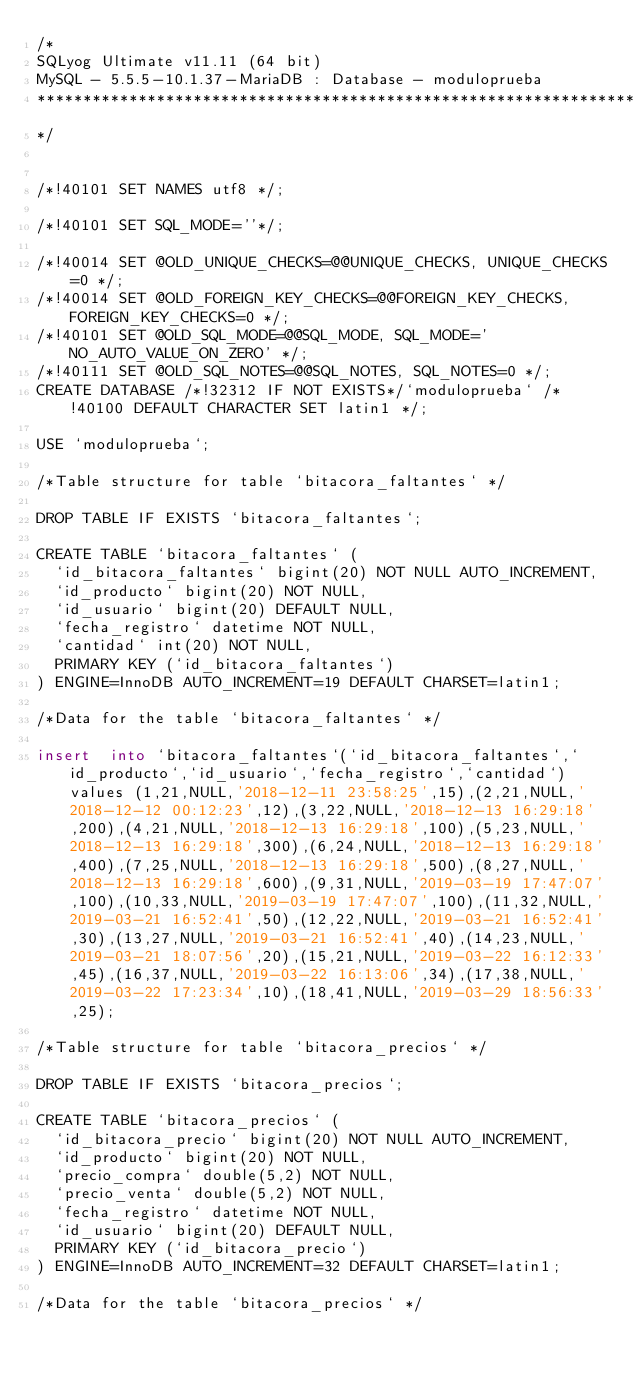Convert code to text. <code><loc_0><loc_0><loc_500><loc_500><_SQL_>/*
SQLyog Ultimate v11.11 (64 bit)
MySQL - 5.5.5-10.1.37-MariaDB : Database - moduloprueba
*********************************************************************
*/

/*!40101 SET NAMES utf8 */;

/*!40101 SET SQL_MODE=''*/;

/*!40014 SET @OLD_UNIQUE_CHECKS=@@UNIQUE_CHECKS, UNIQUE_CHECKS=0 */;
/*!40014 SET @OLD_FOREIGN_KEY_CHECKS=@@FOREIGN_KEY_CHECKS, FOREIGN_KEY_CHECKS=0 */;
/*!40101 SET @OLD_SQL_MODE=@@SQL_MODE, SQL_MODE='NO_AUTO_VALUE_ON_ZERO' */;
/*!40111 SET @OLD_SQL_NOTES=@@SQL_NOTES, SQL_NOTES=0 */;
CREATE DATABASE /*!32312 IF NOT EXISTS*/`moduloprueba` /*!40100 DEFAULT CHARACTER SET latin1 */;

USE `moduloprueba`;

/*Table structure for table `bitacora_faltantes` */

DROP TABLE IF EXISTS `bitacora_faltantes`;

CREATE TABLE `bitacora_faltantes` (
  `id_bitacora_faltantes` bigint(20) NOT NULL AUTO_INCREMENT,
  `id_producto` bigint(20) NOT NULL,
  `id_usuario` bigint(20) DEFAULT NULL,
  `fecha_registro` datetime NOT NULL,
  `cantidad` int(20) NOT NULL,
  PRIMARY KEY (`id_bitacora_faltantes`)
) ENGINE=InnoDB AUTO_INCREMENT=19 DEFAULT CHARSET=latin1;

/*Data for the table `bitacora_faltantes` */

insert  into `bitacora_faltantes`(`id_bitacora_faltantes`,`id_producto`,`id_usuario`,`fecha_registro`,`cantidad`) values (1,21,NULL,'2018-12-11 23:58:25',15),(2,21,NULL,'2018-12-12 00:12:23',12),(3,22,NULL,'2018-12-13 16:29:18',200),(4,21,NULL,'2018-12-13 16:29:18',100),(5,23,NULL,'2018-12-13 16:29:18',300),(6,24,NULL,'2018-12-13 16:29:18',400),(7,25,NULL,'2018-12-13 16:29:18',500),(8,27,NULL,'2018-12-13 16:29:18',600),(9,31,NULL,'2019-03-19 17:47:07',100),(10,33,NULL,'2019-03-19 17:47:07',100),(11,32,NULL,'2019-03-21 16:52:41',50),(12,22,NULL,'2019-03-21 16:52:41',30),(13,27,NULL,'2019-03-21 16:52:41',40),(14,23,NULL,'2019-03-21 18:07:56',20),(15,21,NULL,'2019-03-22 16:12:33',45),(16,37,NULL,'2019-03-22 16:13:06',34),(17,38,NULL,'2019-03-22 17:23:34',10),(18,41,NULL,'2019-03-29 18:56:33',25);

/*Table structure for table `bitacora_precios` */

DROP TABLE IF EXISTS `bitacora_precios`;

CREATE TABLE `bitacora_precios` (
  `id_bitacora_precio` bigint(20) NOT NULL AUTO_INCREMENT,
  `id_producto` bigint(20) NOT NULL,
  `precio_compra` double(5,2) NOT NULL,
  `precio_venta` double(5,2) NOT NULL,
  `fecha_registro` datetime NOT NULL,
  `id_usuario` bigint(20) DEFAULT NULL,
  PRIMARY KEY (`id_bitacora_precio`)
) ENGINE=InnoDB AUTO_INCREMENT=32 DEFAULT CHARSET=latin1;

/*Data for the table `bitacora_precios` */
</code> 